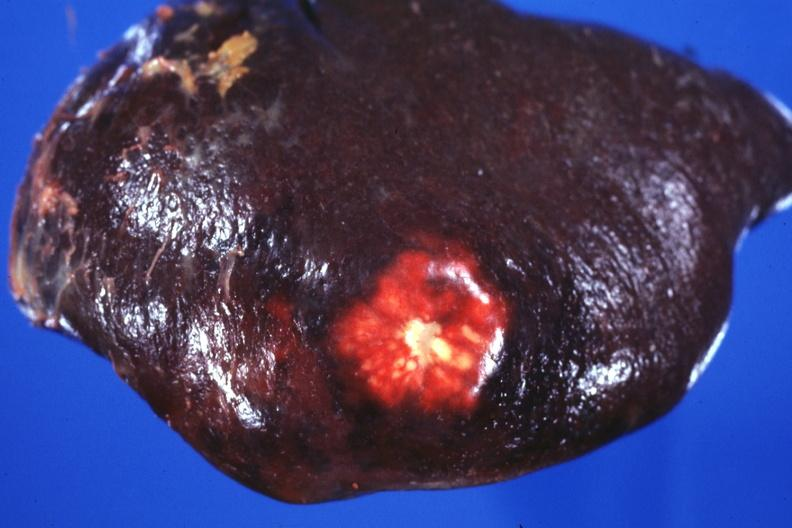s esophagus present?
Answer the question using a single word or phrase. No 